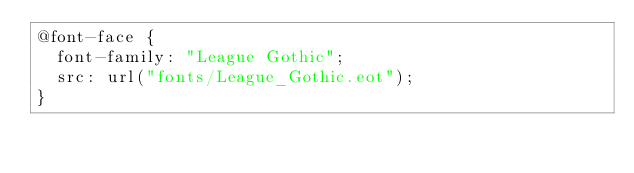<code> <loc_0><loc_0><loc_500><loc_500><_CSS_>@font-face {
  font-family: "League Gothic";
  src: url("fonts/League_Gothic.eot");
}


</code> 